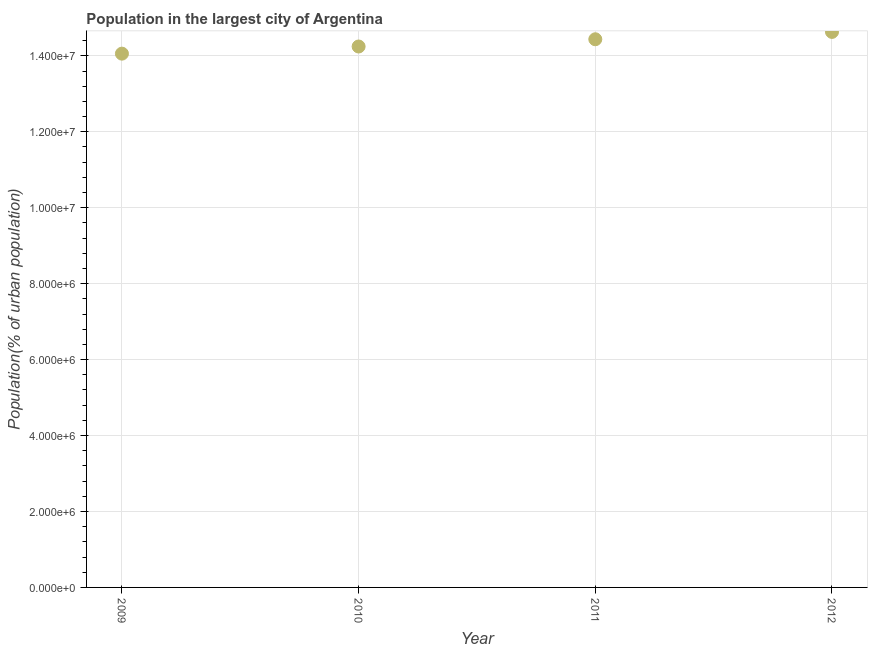What is the population in largest city in 2009?
Ensure brevity in your answer.  1.41e+07. Across all years, what is the maximum population in largest city?
Provide a short and direct response. 1.46e+07. Across all years, what is the minimum population in largest city?
Keep it short and to the point. 1.41e+07. What is the sum of the population in largest city?
Offer a terse response. 5.74e+07. What is the difference between the population in largest city in 2009 and 2012?
Give a very brief answer. -5.72e+05. What is the average population in largest city per year?
Your answer should be very brief. 1.43e+07. What is the median population in largest city?
Keep it short and to the point. 1.43e+07. Do a majority of the years between 2010 and 2011 (inclusive) have population in largest city greater than 8400000 %?
Offer a terse response. Yes. What is the ratio of the population in largest city in 2009 to that in 2012?
Offer a terse response. 0.96. Is the population in largest city in 2010 less than that in 2011?
Offer a very short reply. Yes. What is the difference between the highest and the second highest population in largest city?
Your response must be concise. 1.94e+05. What is the difference between the highest and the lowest population in largest city?
Your answer should be compact. 5.72e+05. How many years are there in the graph?
Offer a very short reply. 4. What is the title of the graph?
Offer a terse response. Population in the largest city of Argentina. What is the label or title of the X-axis?
Ensure brevity in your answer.  Year. What is the label or title of the Y-axis?
Offer a terse response. Population(% of urban population). What is the Population(% of urban population) in 2009?
Provide a short and direct response. 1.41e+07. What is the Population(% of urban population) in 2010?
Provide a short and direct response. 1.42e+07. What is the Population(% of urban population) in 2011?
Your response must be concise. 1.44e+07. What is the Population(% of urban population) in 2012?
Your answer should be compact. 1.46e+07. What is the difference between the Population(% of urban population) in 2009 and 2010?
Make the answer very short. -1.88e+05. What is the difference between the Population(% of urban population) in 2009 and 2011?
Offer a terse response. -3.79e+05. What is the difference between the Population(% of urban population) in 2009 and 2012?
Your answer should be very brief. -5.72e+05. What is the difference between the Population(% of urban population) in 2010 and 2011?
Offer a very short reply. -1.91e+05. What is the difference between the Population(% of urban population) in 2010 and 2012?
Make the answer very short. -3.84e+05. What is the difference between the Population(% of urban population) in 2011 and 2012?
Your answer should be compact. -1.94e+05. What is the ratio of the Population(% of urban population) in 2010 to that in 2012?
Your answer should be very brief. 0.97. 